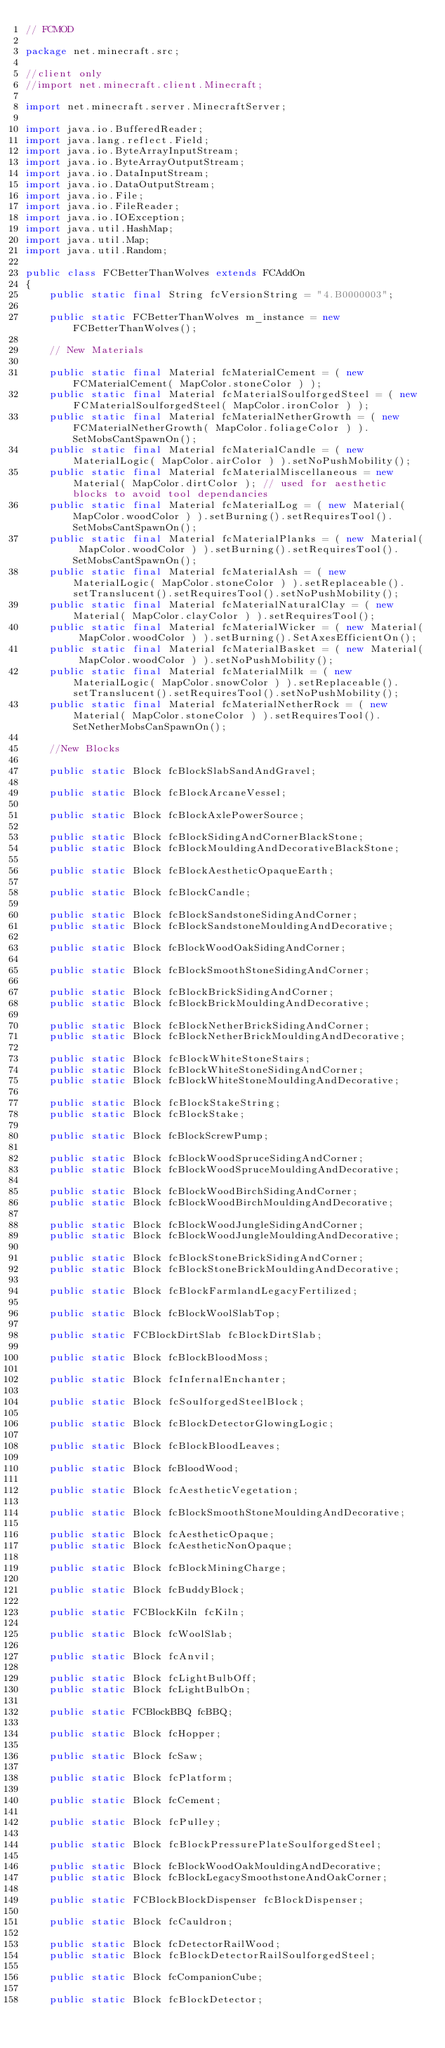Convert code to text. <code><loc_0><loc_0><loc_500><loc_500><_Java_>// FCMOD

package net.minecraft.src;

//client only
//import net.minecraft.client.Minecraft;

import net.minecraft.server.MinecraftServer;

import java.io.BufferedReader;
import java.lang.reflect.Field;
import java.io.ByteArrayInputStream;
import java.io.ByteArrayOutputStream;
import java.io.DataInputStream;
import java.io.DataOutputStream;
import java.io.File;
import java.io.FileReader;
import java.io.IOException;
import java.util.HashMap;
import java.util.Map;
import java.util.Random;

public class FCBetterThanWolves extends FCAddOn
{
	public static final String fcVersionString = "4.B0000003";
	
	public static FCBetterThanWolves m_instance = new FCBetterThanWolves();
	
    // New Materials
    
    public static final Material fcMaterialCement = ( new FCMaterialCement( MapColor.stoneColor ) );
    public static final Material fcMaterialSoulforgedSteel = ( new FCMaterialSoulforgedSteel( MapColor.ironColor ) );
    public static final Material fcMaterialNetherGrowth = ( new FCMaterialNetherGrowth( MapColor.foliageColor ) ).SetMobsCantSpawnOn();    
    public static final Material fcMaterialCandle = ( new MaterialLogic( MapColor.airColor ) ).setNoPushMobility();
    public static final Material fcMaterialMiscellaneous = new Material( MapColor.dirtColor ); // used for aesthetic blocks to avoid tool dependancies
    public static final Material fcMaterialLog = ( new Material( MapColor.woodColor ) ).setBurning().setRequiresTool().SetMobsCantSpawnOn();
    public static final Material fcMaterialPlanks = ( new Material( MapColor.woodColor ) ).setBurning().setRequiresTool().SetMobsCantSpawnOn();
    public static final Material fcMaterialAsh = ( new MaterialLogic( MapColor.stoneColor ) ).setReplaceable().setTranslucent().setRequiresTool().setNoPushMobility();
    public static final Material fcMaterialNaturalClay = ( new Material( MapColor.clayColor ) ).setRequiresTool();
    public static final Material fcMaterialWicker = ( new Material( MapColor.woodColor ) ).setBurning().SetAxesEfficientOn();
    public static final Material fcMaterialBasket = ( new Material( MapColor.woodColor ) ).setNoPushMobility();
    public static final Material fcMaterialMilk = ( new MaterialLogic( MapColor.snowColor ) ).setReplaceable().setTranslucent().setRequiresTool().setNoPushMobility();
    public static final Material fcMaterialNetherRock = ( new Material( MapColor.stoneColor ) ).setRequiresTool().SetNetherMobsCanSpawnOn();
    
	//New Blocks

    public static Block fcBlockSlabSandAndGravel;
    
    public static Block fcBlockArcaneVessel;
    
    public static Block fcBlockAxlePowerSource;
    
    public static Block fcBlockSidingAndCornerBlackStone;
    public static Block fcBlockMouldingAndDecorativeBlackStone;
    
    public static Block fcBlockAestheticOpaqueEarth;
    
    public static Block fcBlockCandle;
    
    public static Block fcBlockSandstoneSidingAndCorner;
    public static Block fcBlockSandstoneMouldingAndDecorative;
    
    public static Block fcBlockWoodOakSidingAndCorner;
    
    public static Block fcBlockSmoothStoneSidingAndCorner;
    
    public static Block fcBlockBrickSidingAndCorner;
    public static Block fcBlockBrickMouldingAndDecorative;
    
    public static Block fcBlockNetherBrickSidingAndCorner;
    public static Block fcBlockNetherBrickMouldingAndDecorative;
    
    public static Block fcBlockWhiteStoneStairs;    
    public static Block fcBlockWhiteStoneSidingAndCorner;
    public static Block fcBlockWhiteStoneMouldingAndDecorative;
    
    public static Block fcBlockStakeString;
    public static Block fcBlockStake;

    public static Block fcBlockScrewPump;

    public static Block fcBlockWoodSpruceSidingAndCorner;
    public static Block fcBlockWoodSpruceMouldingAndDecorative;
    
    public static Block fcBlockWoodBirchSidingAndCorner;
    public static Block fcBlockWoodBirchMouldingAndDecorative;
    
    public static Block fcBlockWoodJungleSidingAndCorner;
    public static Block fcBlockWoodJungleMouldingAndDecorative;
    
    public static Block fcBlockStoneBrickSidingAndCorner;
    public static Block fcBlockStoneBrickMouldingAndDecorative;
    
    public static Block fcBlockFarmlandLegacyFertilized;
    
    public static Block fcBlockWoolSlabTop;
    
    public static FCBlockDirtSlab fcBlockDirtSlab;
    
    public static Block fcBlockBloodMoss;
    
    public static Block fcInfernalEnchanter;
    
    public static Block fcSoulforgedSteelBlock;
    
	public static Block fcBlockDetectorGlowingLogic;
	
    public static Block fcBlockBloodLeaves;
    
    public static Block fcBloodWood;
    
    public static Block fcAestheticVegetation;
    
    public static Block fcBlockSmoothStoneMouldingAndDecorative;
    
    public static Block fcAestheticOpaque;
    public static Block fcAestheticNonOpaque;
    
    public static Block fcBlockMiningCharge;
    
    public static Block fcBuddyBlock;
	
	public static FCBlockKiln fcKiln;
	
	public static Block fcWoolSlab;
	
	public static Block fcAnvil;
	
	public static Block fcLightBulbOff;
	public static Block fcLightBulbOn;
	
	public static FCBlockBBQ fcBBQ;
	
	public static Block fcHopper;
	
	public static Block fcSaw;
	
	public static Block fcPlatform;
	
	public static Block fcCement;
	
	public static Block fcPulley;
	
	public static Block fcBlockPressurePlateSoulforgedSteel;
	
	public static Block fcBlockWoodOakMouldingAndDecorative;
	public static Block fcBlockLegacySmoothstoneAndOakCorner;
    
	public static FCBlockBlockDispenser fcBlockDispenser;
	
	public static Block fcCauldron;

	public static Block fcDetectorRailWood;
	public static Block fcBlockDetectorRailSoulforgedSteel;
	
	public static Block fcCompanionCube;
	
	public static Block fcBlockDetector;</code> 